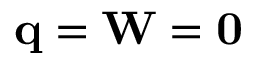<formula> <loc_0><loc_0><loc_500><loc_500>q = W = 0</formula> 